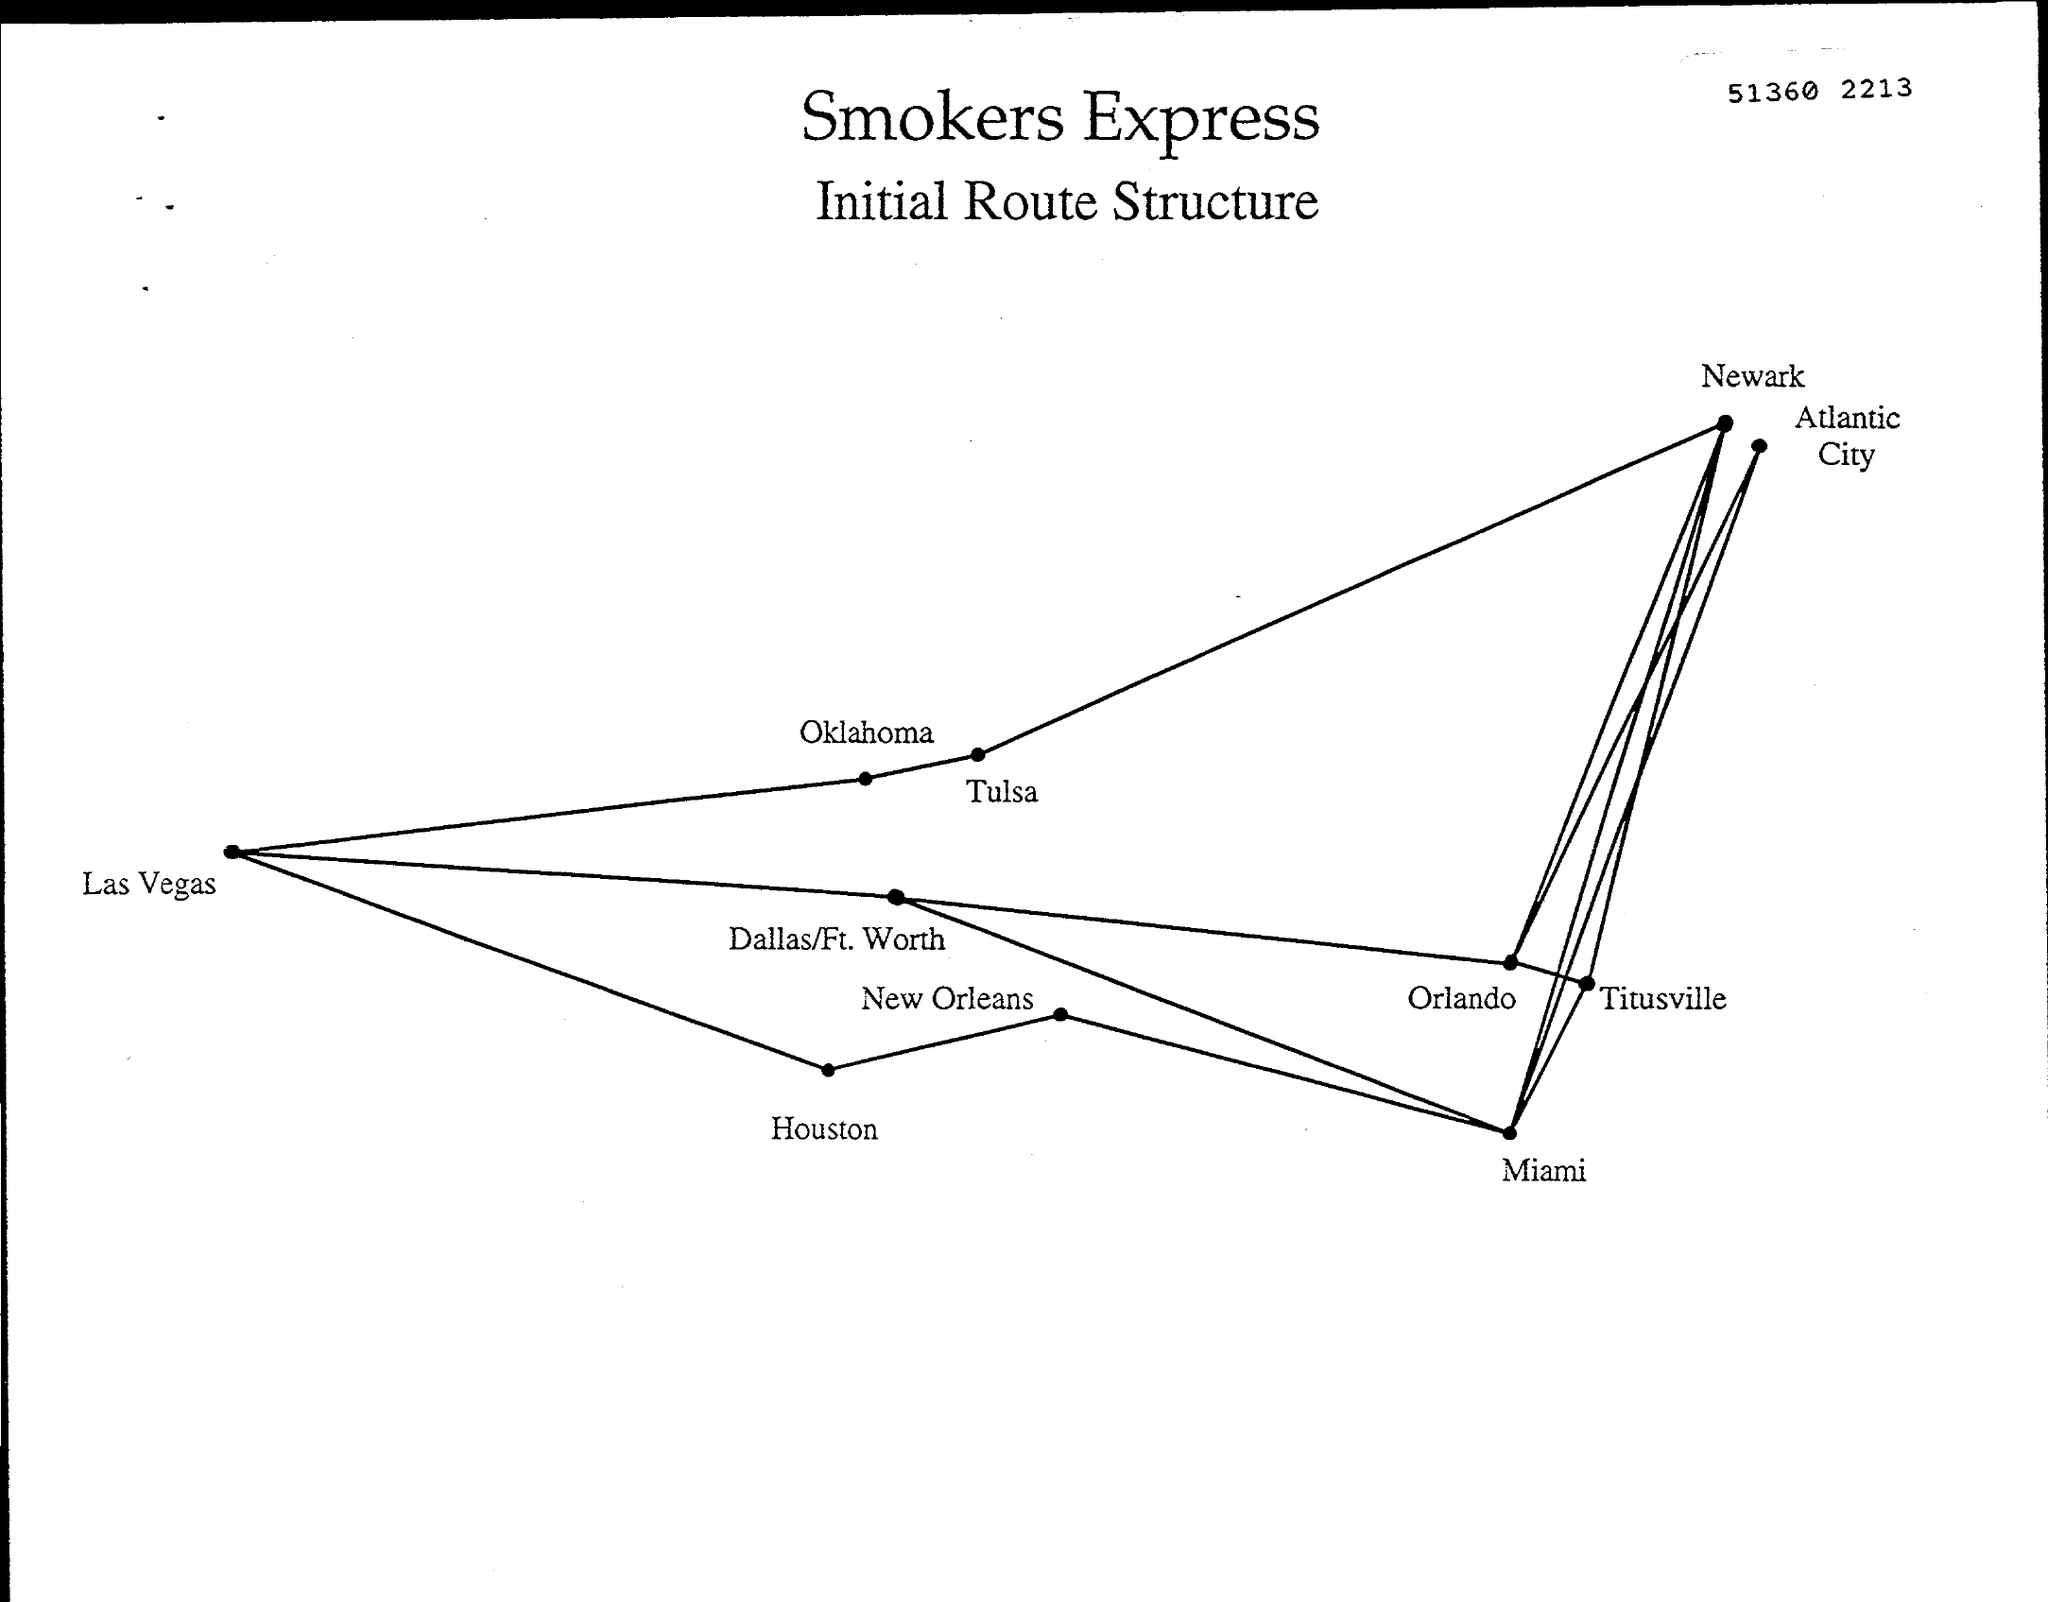What is the document title?
Your answer should be compact. Smokers Express. What is the number on the document?
Provide a succinct answer. 51360 2213. 